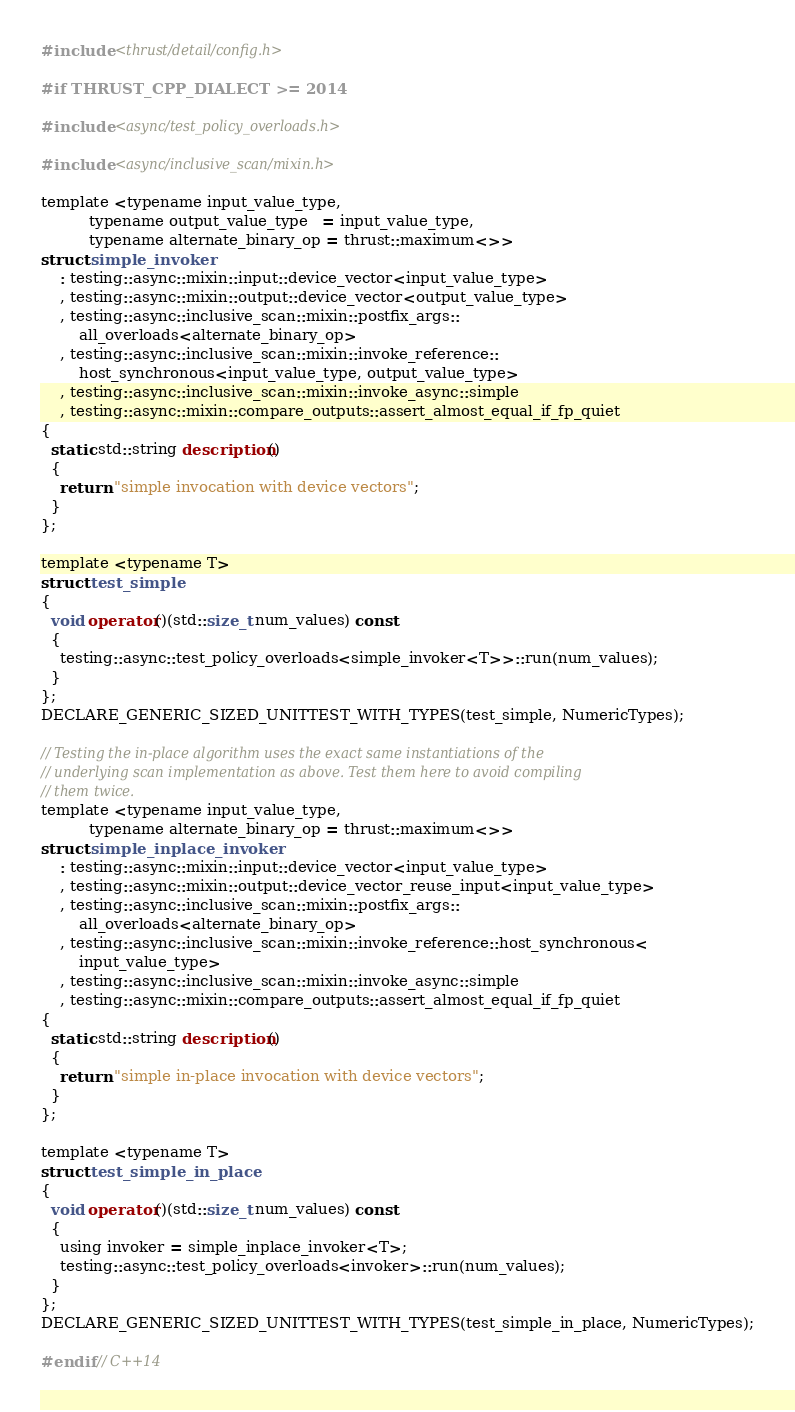<code> <loc_0><loc_0><loc_500><loc_500><_Cuda_>#include <thrust/detail/config.h>

#if THRUST_CPP_DIALECT >= 2014

#include <async/test_policy_overloads.h>

#include <async/inclusive_scan/mixin.h>

template <typename input_value_type,
          typename output_value_type   = input_value_type,
          typename alternate_binary_op = thrust::maximum<>>
struct simple_invoker
    : testing::async::mixin::input::device_vector<input_value_type>
    , testing::async::mixin::output::device_vector<output_value_type>
    , testing::async::inclusive_scan::mixin::postfix_args::
        all_overloads<alternate_binary_op>
    , testing::async::inclusive_scan::mixin::invoke_reference::
        host_synchronous<input_value_type, output_value_type>
    , testing::async::inclusive_scan::mixin::invoke_async::simple
    , testing::async::mixin::compare_outputs::assert_almost_equal_if_fp_quiet
{
  static std::string description()
  {
    return "simple invocation with device vectors";
  }
};

template <typename T>
struct test_simple
{
  void operator()(std::size_t num_values) const
  {
    testing::async::test_policy_overloads<simple_invoker<T>>::run(num_values);
  }
};
DECLARE_GENERIC_SIZED_UNITTEST_WITH_TYPES(test_simple, NumericTypes);

// Testing the in-place algorithm uses the exact same instantiations of the
// underlying scan implementation as above. Test them here to avoid compiling
// them twice.
template <typename input_value_type,
          typename alternate_binary_op = thrust::maximum<>>
struct simple_inplace_invoker
    : testing::async::mixin::input::device_vector<input_value_type>
    , testing::async::mixin::output::device_vector_reuse_input<input_value_type>
    , testing::async::inclusive_scan::mixin::postfix_args::
        all_overloads<alternate_binary_op>
    , testing::async::inclusive_scan::mixin::invoke_reference::host_synchronous<
        input_value_type>
    , testing::async::inclusive_scan::mixin::invoke_async::simple
    , testing::async::mixin::compare_outputs::assert_almost_equal_if_fp_quiet
{
  static std::string description()
  {
    return "simple in-place invocation with device vectors";
  }
};

template <typename T>
struct test_simple_in_place
{
  void operator()(std::size_t num_values) const
  {
    using invoker = simple_inplace_invoker<T>;
    testing::async::test_policy_overloads<invoker>::run(num_values);
  }
};
DECLARE_GENERIC_SIZED_UNITTEST_WITH_TYPES(test_simple_in_place, NumericTypes);

#endif // C++14
</code> 